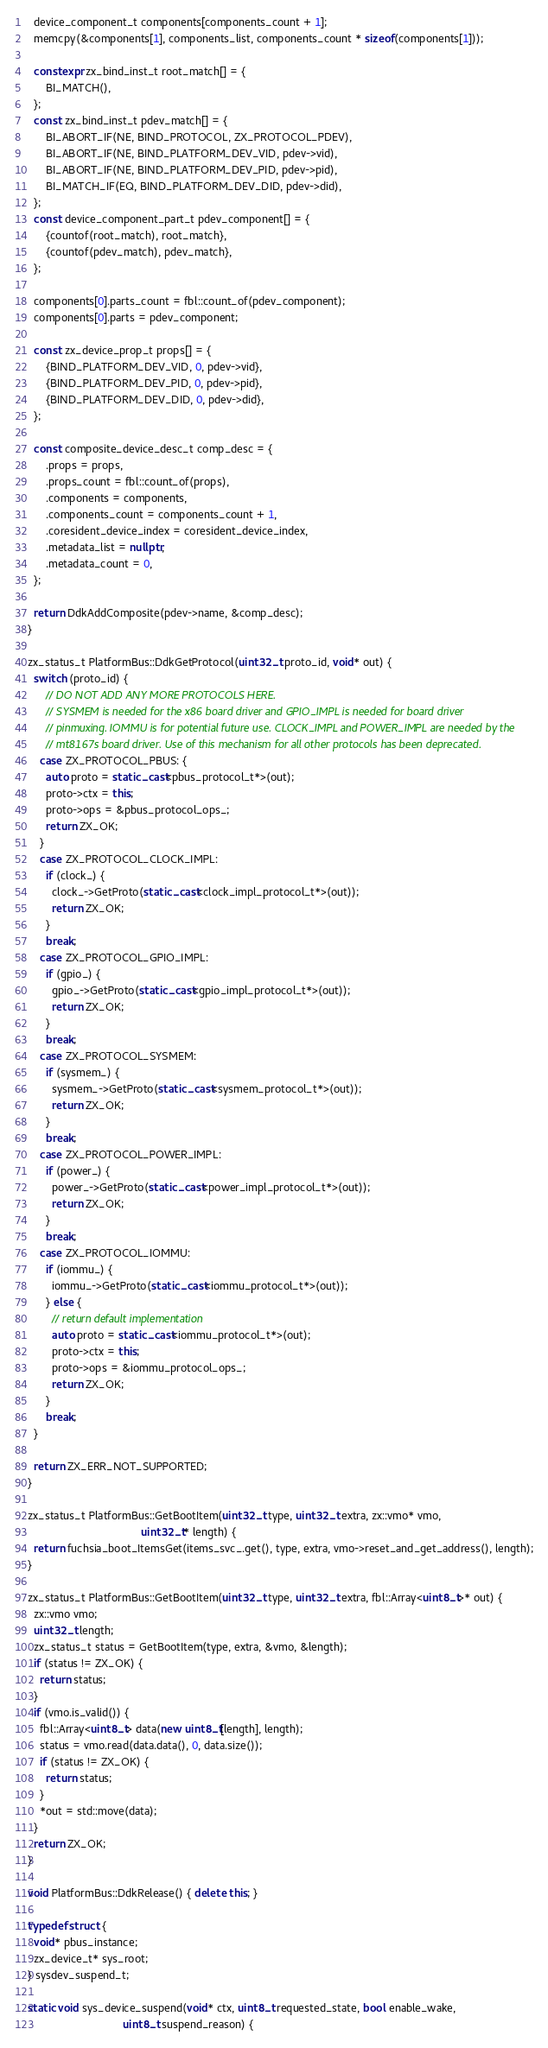<code> <loc_0><loc_0><loc_500><loc_500><_C++_>
  device_component_t components[components_count + 1];
  memcpy(&components[1], components_list, components_count * sizeof(components[1]));

  constexpr zx_bind_inst_t root_match[] = {
      BI_MATCH(),
  };
  const zx_bind_inst_t pdev_match[] = {
      BI_ABORT_IF(NE, BIND_PROTOCOL, ZX_PROTOCOL_PDEV),
      BI_ABORT_IF(NE, BIND_PLATFORM_DEV_VID, pdev->vid),
      BI_ABORT_IF(NE, BIND_PLATFORM_DEV_PID, pdev->pid),
      BI_MATCH_IF(EQ, BIND_PLATFORM_DEV_DID, pdev->did),
  };
  const device_component_part_t pdev_component[] = {
      {countof(root_match), root_match},
      {countof(pdev_match), pdev_match},
  };

  components[0].parts_count = fbl::count_of(pdev_component);
  components[0].parts = pdev_component;

  const zx_device_prop_t props[] = {
      {BIND_PLATFORM_DEV_VID, 0, pdev->vid},
      {BIND_PLATFORM_DEV_PID, 0, pdev->pid},
      {BIND_PLATFORM_DEV_DID, 0, pdev->did},
  };

  const composite_device_desc_t comp_desc = {
      .props = props,
      .props_count = fbl::count_of(props),
      .components = components,
      .components_count = components_count + 1,
      .coresident_device_index = coresident_device_index,
      .metadata_list = nullptr,
      .metadata_count = 0,
  };

  return DdkAddComposite(pdev->name, &comp_desc);
}

zx_status_t PlatformBus::DdkGetProtocol(uint32_t proto_id, void* out) {
  switch (proto_id) {
      // DO NOT ADD ANY MORE PROTOCOLS HERE.
      // SYSMEM is needed for the x86 board driver and GPIO_IMPL is needed for board driver
      // pinmuxing. IOMMU is for potential future use. CLOCK_IMPL and POWER_IMPL are needed by the
      // mt8167s board driver. Use of this mechanism for all other protocols has been deprecated.
    case ZX_PROTOCOL_PBUS: {
      auto proto = static_cast<pbus_protocol_t*>(out);
      proto->ctx = this;
      proto->ops = &pbus_protocol_ops_;
      return ZX_OK;
    }
    case ZX_PROTOCOL_CLOCK_IMPL:
      if (clock_) {
        clock_->GetProto(static_cast<clock_impl_protocol_t*>(out));
        return ZX_OK;
      }
      break;
    case ZX_PROTOCOL_GPIO_IMPL:
      if (gpio_) {
        gpio_->GetProto(static_cast<gpio_impl_protocol_t*>(out));
        return ZX_OK;
      }
      break;
    case ZX_PROTOCOL_SYSMEM:
      if (sysmem_) {
        sysmem_->GetProto(static_cast<sysmem_protocol_t*>(out));
        return ZX_OK;
      }
      break;
    case ZX_PROTOCOL_POWER_IMPL:
      if (power_) {
        power_->GetProto(static_cast<power_impl_protocol_t*>(out));
        return ZX_OK;
      }
      break;
    case ZX_PROTOCOL_IOMMU:
      if (iommu_) {
        iommu_->GetProto(static_cast<iommu_protocol_t*>(out));
      } else {
        // return default implementation
        auto proto = static_cast<iommu_protocol_t*>(out);
        proto->ctx = this;
        proto->ops = &iommu_protocol_ops_;
        return ZX_OK;
      }
      break;
  }

  return ZX_ERR_NOT_SUPPORTED;
}

zx_status_t PlatformBus::GetBootItem(uint32_t type, uint32_t extra, zx::vmo* vmo,
                                     uint32_t* length) {
  return fuchsia_boot_ItemsGet(items_svc_.get(), type, extra, vmo->reset_and_get_address(), length);
}

zx_status_t PlatformBus::GetBootItem(uint32_t type, uint32_t extra, fbl::Array<uint8_t>* out) {
  zx::vmo vmo;
  uint32_t length;
  zx_status_t status = GetBootItem(type, extra, &vmo, &length);
  if (status != ZX_OK) {
    return status;
  }
  if (vmo.is_valid()) {
    fbl::Array<uint8_t> data(new uint8_t[length], length);
    status = vmo.read(data.data(), 0, data.size());
    if (status != ZX_OK) {
      return status;
    }
    *out = std::move(data);
  }
  return ZX_OK;
}

void PlatformBus::DdkRelease() { delete this; }

typedef struct {
  void* pbus_instance;
  zx_device_t* sys_root;
} sysdev_suspend_t;

static void sys_device_suspend(void* ctx, uint8_t requested_state, bool enable_wake,
                               uint8_t suspend_reason) {</code> 